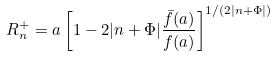<formula> <loc_0><loc_0><loc_500><loc_500>R _ { n } ^ { + } = a \left [ 1 - 2 | n + \Phi | \frac { \bar { f } ( a ) } { f ( a ) } \right ] ^ { 1 / ( 2 | n + \Phi | ) }</formula> 